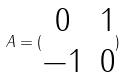Convert formula to latex. <formula><loc_0><loc_0><loc_500><loc_500>A = ( \begin{matrix} 0 & 1 \\ - 1 & 0 \end{matrix} )</formula> 